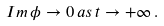<formula> <loc_0><loc_0><loc_500><loc_500>I m \, \phi \to 0 \, a s \, t \to + \infty \, .</formula> 